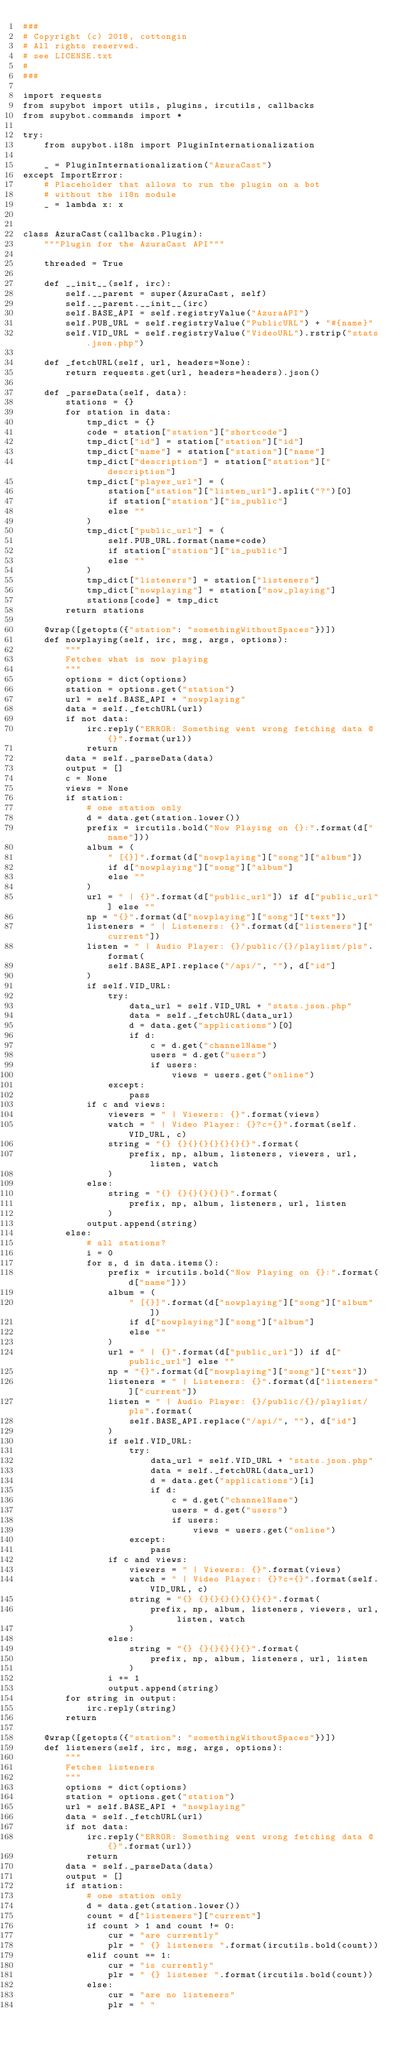<code> <loc_0><loc_0><loc_500><loc_500><_Python_>###
# Copyright (c) 2018, cottongin
# All rights reserved.
# see LICENSE.txt
#
###

import requests
from supybot import utils, plugins, ircutils, callbacks
from supybot.commands import *

try:
    from supybot.i18n import PluginInternationalization

    _ = PluginInternationalization("AzuraCast")
except ImportError:
    # Placeholder that allows to run the plugin on a bot
    # without the i18n module
    _ = lambda x: x


class AzuraCast(callbacks.Plugin):
    """Plugin for the AzuraCast API"""

    threaded = True

    def __init__(self, irc):
        self.__parent = super(AzuraCast, self)
        self.__parent.__init__(irc)
        self.BASE_API = self.registryValue("AzuraAPI")
        self.PUB_URL = self.registryValue("PublicURL") + "#{name}"
        self.VID_URL = self.registryValue("VideoURL").rstrip("stats.json.php")

    def _fetchURL(self, url, headers=None):
        return requests.get(url, headers=headers).json()

    def _parseData(self, data):
        stations = {}
        for station in data:
            tmp_dict = {}
            code = station["station"]["shortcode"]
            tmp_dict["id"] = station["station"]["id"]
            tmp_dict["name"] = station["station"]["name"]
            tmp_dict["description"] = station["station"]["description"]
            tmp_dict["player_url"] = (
                station["station"]["listen_url"].split("?")[0]
                if station["station"]["is_public"]
                else ""
            )
            tmp_dict["public_url"] = (
                self.PUB_URL.format(name=code)
                if station["station"]["is_public"]
                else ""
            )
            tmp_dict["listeners"] = station["listeners"]
            tmp_dict["nowplaying"] = station["now_playing"]
            stations[code] = tmp_dict
        return stations

    @wrap([getopts({"station": "somethingWithoutSpaces"})])
    def nowplaying(self, irc, msg, args, options):
        """
        Fetches what is now playing
        """
        options = dict(options)
        station = options.get("station")
        url = self.BASE_API + "nowplaying"
        data = self._fetchURL(url)
        if not data:
            irc.reply("ERROR: Something went wrong fetching data @ {}".format(url))
            return
        data = self._parseData(data)
        output = []
        c = None
        views = None
        if station:
            # one station only
            d = data.get(station.lower())
            prefix = ircutils.bold("Now Playing on {}:".format(d["name"]))
            album = (
                " [{}]".format(d["nowplaying"]["song"]["album"])
                if d["nowplaying"]["song"]["album"]
                else ""
            )
            url = " | {}".format(d["public_url"]) if d["public_url"] else ""
            np = "{}".format(d["nowplaying"]["song"]["text"])
            listeners = " | Listeners: {}".format(d["listeners"]["current"])
            listen = " | Audio Player: {}/public/{}/playlist/pls".format(
                self.BASE_API.replace("/api/", ""), d["id"]
            )
            if self.VID_URL:
                try:
                    data_url = self.VID_URL + "stats.json.php"
                    data = self._fetchURL(data_url)
                    d = data.get("applications")[0]
                    if d:
                        c = d.get("channelName")
                        users = d.get("users")
                        if users:
                            views = users.get("online")
                except:
                    pass
            if c and views:
                viewers = " | Viewers: {}".format(views)
                watch = " | Video Player: {}?c={}".format(self.VID_URL, c)
                string = "{} {}{}{}{}{}{}{}".format(
                    prefix, np, album, listeners, viewers, url, listen, watch
                )
            else:
                string = "{} {}{}{}{}{}".format(
                    prefix, np, album, listeners, url, listen
                )
            output.append(string)
        else:
            # all stations?
            i = 0
            for s, d in data.items():
                prefix = ircutils.bold("Now Playing on {}:".format(d["name"]))
                album = (
                    " [{}]".format(d["nowplaying"]["song"]["album"])
                    if d["nowplaying"]["song"]["album"]
                    else ""
                )
                url = " | {}".format(d["public_url"]) if d["public_url"] else ""
                np = "{}".format(d["nowplaying"]["song"]["text"])
                listeners = " | Listeners: {}".format(d["listeners"]["current"])
                listen = " | Audio Player: {}/public/{}/playlist/pls".format(
                    self.BASE_API.replace("/api/", ""), d["id"]
                )
                if self.VID_URL:
                    try:
                        data_url = self.VID_URL + "stats.json.php"
                        data = self._fetchURL(data_url)
                        d = data.get("applications")[i]
                        if d:
                            c = d.get("channelName")
                            users = d.get("users")
                            if users:
                                views = users.get("online")
                    except:
                        pass
                if c and views:
                    viewers = " | Viewers: {}".format(views)
                    watch = " | Video Player: {}?c={}".format(self.VID_URL, c)
                    string = "{} {}{}{}{}{}{}{}".format(
                        prefix, np, album, listeners, viewers, url, listen, watch
                    )
                else:
                    string = "{} {}{}{}{}{}".format(
                        prefix, np, album, listeners, url, listen
                    )
                i += 1
                output.append(string)
        for string in output:
            irc.reply(string)
        return

    @wrap([getopts({"station": "somethingWithoutSpaces"})])
    def listeners(self, irc, msg, args, options):
        """
        Fetches listeners
        """
        options = dict(options)
        station = options.get("station")
        url = self.BASE_API + "nowplaying"
        data = self._fetchURL(url)
        if not data:
            irc.reply("ERROR: Something went wrong fetching data @ {}".format(url))
            return
        data = self._parseData(data)
        output = []
        if station:
            # one station only
            d = data.get(station.lower())
            count = d["listeners"]["current"]
            if count > 1 and count != 0:
                cur = "are currently"
                plr = " {} listeners ".format(ircutils.bold(count))
            elif count == 1:
                cur = "is currently"
                plr = " {} listener ".format(ircutils.bold(count))
            else:
                cur = "are no listeners"
                plr = " "</code> 